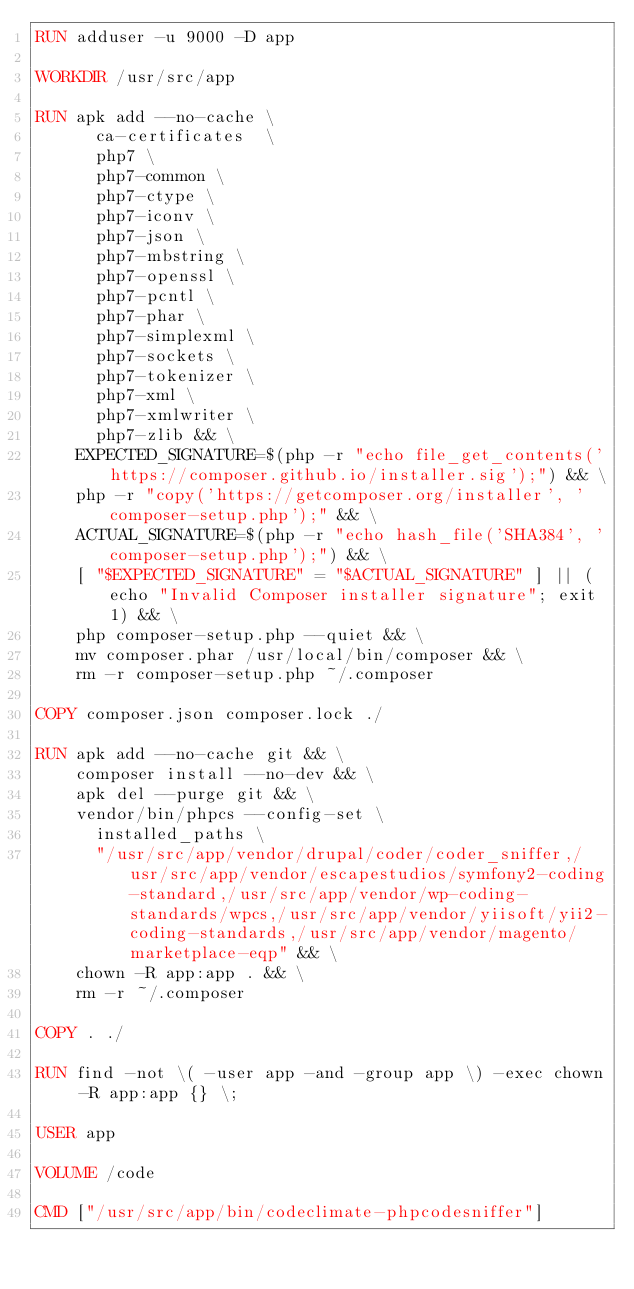Convert code to text. <code><loc_0><loc_0><loc_500><loc_500><_Dockerfile_>RUN adduser -u 9000 -D app

WORKDIR /usr/src/app

RUN apk add --no-cache \
      ca-certificates  \
      php7 \
      php7-common \
      php7-ctype \
      php7-iconv \
      php7-json \
      php7-mbstring \
      php7-openssl \
      php7-pcntl \
      php7-phar \
      php7-simplexml \
      php7-sockets \
      php7-tokenizer \
      php7-xml \
      php7-xmlwriter \
      php7-zlib && \
    EXPECTED_SIGNATURE=$(php -r "echo file_get_contents('https://composer.github.io/installer.sig');") && \
    php -r "copy('https://getcomposer.org/installer', 'composer-setup.php');" && \
    ACTUAL_SIGNATURE=$(php -r "echo hash_file('SHA384', 'composer-setup.php');") && \
    [ "$EXPECTED_SIGNATURE" = "$ACTUAL_SIGNATURE" ] || (echo "Invalid Composer installer signature"; exit 1) && \
    php composer-setup.php --quiet && \
    mv composer.phar /usr/local/bin/composer && \
    rm -r composer-setup.php ~/.composer

COPY composer.json composer.lock ./

RUN apk add --no-cache git && \
    composer install --no-dev && \
    apk del --purge git && \
    vendor/bin/phpcs --config-set \
      installed_paths \
      "/usr/src/app/vendor/drupal/coder/coder_sniffer,/usr/src/app/vendor/escapestudios/symfony2-coding-standard,/usr/src/app/vendor/wp-coding-standards/wpcs,/usr/src/app/vendor/yiisoft/yii2-coding-standards,/usr/src/app/vendor/magento/marketplace-eqp" && \
    chown -R app:app . && \
    rm -r ~/.composer

COPY . ./

RUN find -not \( -user app -and -group app \) -exec chown -R app:app {} \;

USER app

VOLUME /code

CMD ["/usr/src/app/bin/codeclimate-phpcodesniffer"]
</code> 